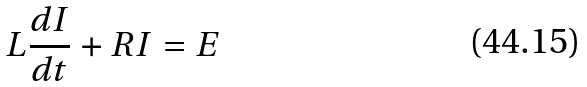<formula> <loc_0><loc_0><loc_500><loc_500>L \frac { d I } { d t } + R I = E</formula> 